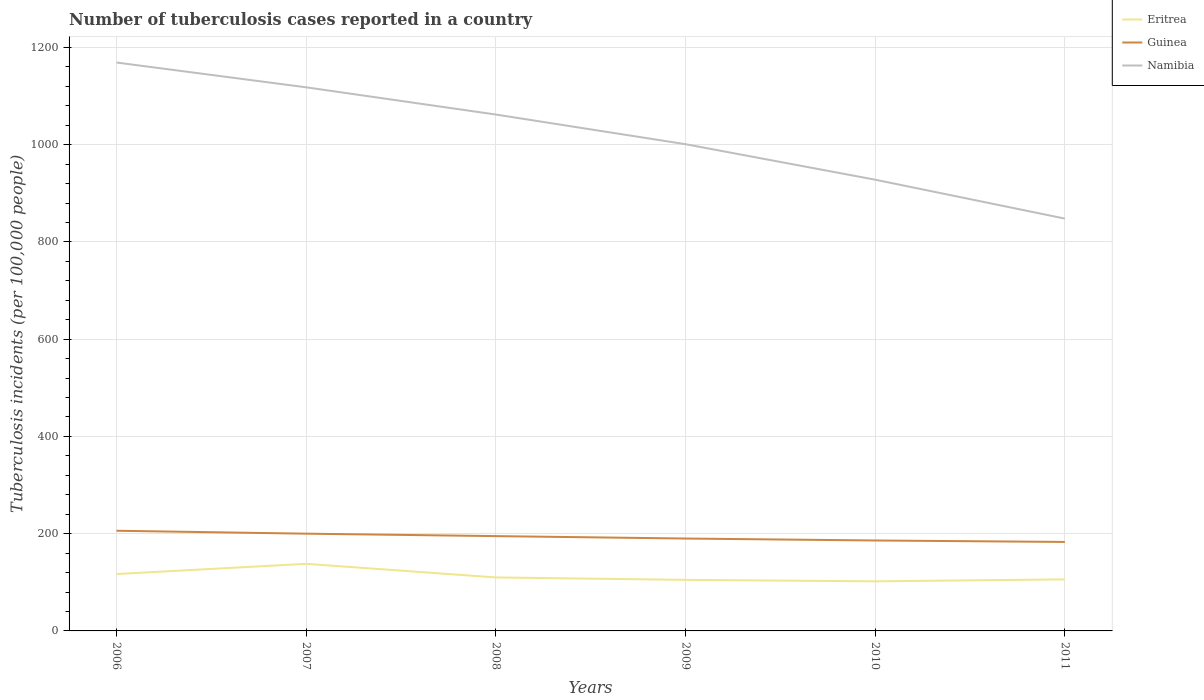Does the line corresponding to Eritrea intersect with the line corresponding to Namibia?
Provide a succinct answer. No. Across all years, what is the maximum number of tuberculosis cases reported in in Guinea?
Keep it short and to the point. 183. What is the total number of tuberculosis cases reported in in Eritrea in the graph?
Keep it short and to the point. 32. What is the difference between the highest and the second highest number of tuberculosis cases reported in in Namibia?
Your answer should be compact. 321. What is the difference between the highest and the lowest number of tuberculosis cases reported in in Guinea?
Your response must be concise. 3. Is the number of tuberculosis cases reported in in Guinea strictly greater than the number of tuberculosis cases reported in in Eritrea over the years?
Offer a very short reply. No. How many lines are there?
Offer a very short reply. 3. How many years are there in the graph?
Provide a short and direct response. 6. What is the difference between two consecutive major ticks on the Y-axis?
Provide a succinct answer. 200. Does the graph contain grids?
Your response must be concise. Yes. Where does the legend appear in the graph?
Your response must be concise. Top right. How many legend labels are there?
Your response must be concise. 3. How are the legend labels stacked?
Provide a succinct answer. Vertical. What is the title of the graph?
Ensure brevity in your answer.  Number of tuberculosis cases reported in a country. What is the label or title of the Y-axis?
Your answer should be compact. Tuberculosis incidents (per 100,0 people). What is the Tuberculosis incidents (per 100,000 people) in Eritrea in 2006?
Keep it short and to the point. 117. What is the Tuberculosis incidents (per 100,000 people) in Guinea in 2006?
Provide a short and direct response. 206. What is the Tuberculosis incidents (per 100,000 people) in Namibia in 2006?
Your answer should be very brief. 1169. What is the Tuberculosis incidents (per 100,000 people) of Eritrea in 2007?
Offer a very short reply. 138. What is the Tuberculosis incidents (per 100,000 people) in Guinea in 2007?
Your answer should be compact. 200. What is the Tuberculosis incidents (per 100,000 people) in Namibia in 2007?
Give a very brief answer. 1118. What is the Tuberculosis incidents (per 100,000 people) of Eritrea in 2008?
Keep it short and to the point. 110. What is the Tuberculosis incidents (per 100,000 people) of Guinea in 2008?
Ensure brevity in your answer.  195. What is the Tuberculosis incidents (per 100,000 people) of Namibia in 2008?
Your response must be concise. 1062. What is the Tuberculosis incidents (per 100,000 people) in Eritrea in 2009?
Make the answer very short. 105. What is the Tuberculosis incidents (per 100,000 people) of Guinea in 2009?
Provide a short and direct response. 190. What is the Tuberculosis incidents (per 100,000 people) in Namibia in 2009?
Your response must be concise. 1001. What is the Tuberculosis incidents (per 100,000 people) of Eritrea in 2010?
Make the answer very short. 102. What is the Tuberculosis incidents (per 100,000 people) in Guinea in 2010?
Your response must be concise. 186. What is the Tuberculosis incidents (per 100,000 people) of Namibia in 2010?
Give a very brief answer. 928. What is the Tuberculosis incidents (per 100,000 people) in Eritrea in 2011?
Offer a very short reply. 106. What is the Tuberculosis incidents (per 100,000 people) of Guinea in 2011?
Provide a short and direct response. 183. What is the Tuberculosis incidents (per 100,000 people) of Namibia in 2011?
Your answer should be very brief. 848. Across all years, what is the maximum Tuberculosis incidents (per 100,000 people) of Eritrea?
Keep it short and to the point. 138. Across all years, what is the maximum Tuberculosis incidents (per 100,000 people) in Guinea?
Your response must be concise. 206. Across all years, what is the maximum Tuberculosis incidents (per 100,000 people) in Namibia?
Keep it short and to the point. 1169. Across all years, what is the minimum Tuberculosis incidents (per 100,000 people) in Eritrea?
Offer a terse response. 102. Across all years, what is the minimum Tuberculosis incidents (per 100,000 people) in Guinea?
Provide a succinct answer. 183. Across all years, what is the minimum Tuberculosis incidents (per 100,000 people) in Namibia?
Provide a short and direct response. 848. What is the total Tuberculosis incidents (per 100,000 people) in Eritrea in the graph?
Your response must be concise. 678. What is the total Tuberculosis incidents (per 100,000 people) in Guinea in the graph?
Offer a very short reply. 1160. What is the total Tuberculosis incidents (per 100,000 people) of Namibia in the graph?
Provide a short and direct response. 6126. What is the difference between the Tuberculosis incidents (per 100,000 people) of Eritrea in 2006 and that in 2008?
Give a very brief answer. 7. What is the difference between the Tuberculosis incidents (per 100,000 people) in Namibia in 2006 and that in 2008?
Offer a very short reply. 107. What is the difference between the Tuberculosis incidents (per 100,000 people) in Guinea in 2006 and that in 2009?
Provide a short and direct response. 16. What is the difference between the Tuberculosis incidents (per 100,000 people) of Namibia in 2006 and that in 2009?
Your answer should be very brief. 168. What is the difference between the Tuberculosis incidents (per 100,000 people) of Eritrea in 2006 and that in 2010?
Make the answer very short. 15. What is the difference between the Tuberculosis incidents (per 100,000 people) of Guinea in 2006 and that in 2010?
Offer a very short reply. 20. What is the difference between the Tuberculosis incidents (per 100,000 people) of Namibia in 2006 and that in 2010?
Your answer should be very brief. 241. What is the difference between the Tuberculosis incidents (per 100,000 people) of Eritrea in 2006 and that in 2011?
Your answer should be compact. 11. What is the difference between the Tuberculosis incidents (per 100,000 people) in Namibia in 2006 and that in 2011?
Your answer should be compact. 321. What is the difference between the Tuberculosis incidents (per 100,000 people) in Eritrea in 2007 and that in 2008?
Your response must be concise. 28. What is the difference between the Tuberculosis incidents (per 100,000 people) in Guinea in 2007 and that in 2009?
Make the answer very short. 10. What is the difference between the Tuberculosis incidents (per 100,000 people) of Namibia in 2007 and that in 2009?
Keep it short and to the point. 117. What is the difference between the Tuberculosis incidents (per 100,000 people) in Eritrea in 2007 and that in 2010?
Your answer should be compact. 36. What is the difference between the Tuberculosis incidents (per 100,000 people) of Guinea in 2007 and that in 2010?
Offer a very short reply. 14. What is the difference between the Tuberculosis incidents (per 100,000 people) of Namibia in 2007 and that in 2010?
Your answer should be very brief. 190. What is the difference between the Tuberculosis incidents (per 100,000 people) of Guinea in 2007 and that in 2011?
Keep it short and to the point. 17. What is the difference between the Tuberculosis incidents (per 100,000 people) in Namibia in 2007 and that in 2011?
Provide a short and direct response. 270. What is the difference between the Tuberculosis incidents (per 100,000 people) of Eritrea in 2008 and that in 2009?
Provide a short and direct response. 5. What is the difference between the Tuberculosis incidents (per 100,000 people) in Guinea in 2008 and that in 2010?
Offer a very short reply. 9. What is the difference between the Tuberculosis incidents (per 100,000 people) in Namibia in 2008 and that in 2010?
Offer a terse response. 134. What is the difference between the Tuberculosis incidents (per 100,000 people) in Guinea in 2008 and that in 2011?
Provide a short and direct response. 12. What is the difference between the Tuberculosis incidents (per 100,000 people) of Namibia in 2008 and that in 2011?
Your answer should be very brief. 214. What is the difference between the Tuberculosis incidents (per 100,000 people) in Eritrea in 2009 and that in 2010?
Your answer should be very brief. 3. What is the difference between the Tuberculosis incidents (per 100,000 people) in Guinea in 2009 and that in 2010?
Provide a short and direct response. 4. What is the difference between the Tuberculosis incidents (per 100,000 people) of Guinea in 2009 and that in 2011?
Offer a terse response. 7. What is the difference between the Tuberculosis incidents (per 100,000 people) of Namibia in 2009 and that in 2011?
Keep it short and to the point. 153. What is the difference between the Tuberculosis incidents (per 100,000 people) in Eritrea in 2010 and that in 2011?
Give a very brief answer. -4. What is the difference between the Tuberculosis incidents (per 100,000 people) in Eritrea in 2006 and the Tuberculosis incidents (per 100,000 people) in Guinea in 2007?
Your answer should be very brief. -83. What is the difference between the Tuberculosis incidents (per 100,000 people) in Eritrea in 2006 and the Tuberculosis incidents (per 100,000 people) in Namibia in 2007?
Your answer should be compact. -1001. What is the difference between the Tuberculosis incidents (per 100,000 people) of Guinea in 2006 and the Tuberculosis incidents (per 100,000 people) of Namibia in 2007?
Offer a terse response. -912. What is the difference between the Tuberculosis incidents (per 100,000 people) of Eritrea in 2006 and the Tuberculosis incidents (per 100,000 people) of Guinea in 2008?
Offer a very short reply. -78. What is the difference between the Tuberculosis incidents (per 100,000 people) in Eritrea in 2006 and the Tuberculosis incidents (per 100,000 people) in Namibia in 2008?
Provide a short and direct response. -945. What is the difference between the Tuberculosis incidents (per 100,000 people) in Guinea in 2006 and the Tuberculosis incidents (per 100,000 people) in Namibia in 2008?
Your answer should be very brief. -856. What is the difference between the Tuberculosis incidents (per 100,000 people) of Eritrea in 2006 and the Tuberculosis incidents (per 100,000 people) of Guinea in 2009?
Your answer should be very brief. -73. What is the difference between the Tuberculosis incidents (per 100,000 people) in Eritrea in 2006 and the Tuberculosis incidents (per 100,000 people) in Namibia in 2009?
Provide a short and direct response. -884. What is the difference between the Tuberculosis incidents (per 100,000 people) of Guinea in 2006 and the Tuberculosis incidents (per 100,000 people) of Namibia in 2009?
Make the answer very short. -795. What is the difference between the Tuberculosis incidents (per 100,000 people) in Eritrea in 2006 and the Tuberculosis incidents (per 100,000 people) in Guinea in 2010?
Ensure brevity in your answer.  -69. What is the difference between the Tuberculosis incidents (per 100,000 people) in Eritrea in 2006 and the Tuberculosis incidents (per 100,000 people) in Namibia in 2010?
Provide a short and direct response. -811. What is the difference between the Tuberculosis incidents (per 100,000 people) in Guinea in 2006 and the Tuberculosis incidents (per 100,000 people) in Namibia in 2010?
Give a very brief answer. -722. What is the difference between the Tuberculosis incidents (per 100,000 people) in Eritrea in 2006 and the Tuberculosis incidents (per 100,000 people) in Guinea in 2011?
Offer a very short reply. -66. What is the difference between the Tuberculosis incidents (per 100,000 people) of Eritrea in 2006 and the Tuberculosis incidents (per 100,000 people) of Namibia in 2011?
Make the answer very short. -731. What is the difference between the Tuberculosis incidents (per 100,000 people) of Guinea in 2006 and the Tuberculosis incidents (per 100,000 people) of Namibia in 2011?
Make the answer very short. -642. What is the difference between the Tuberculosis incidents (per 100,000 people) in Eritrea in 2007 and the Tuberculosis incidents (per 100,000 people) in Guinea in 2008?
Offer a terse response. -57. What is the difference between the Tuberculosis incidents (per 100,000 people) in Eritrea in 2007 and the Tuberculosis incidents (per 100,000 people) in Namibia in 2008?
Ensure brevity in your answer.  -924. What is the difference between the Tuberculosis incidents (per 100,000 people) in Guinea in 2007 and the Tuberculosis incidents (per 100,000 people) in Namibia in 2008?
Keep it short and to the point. -862. What is the difference between the Tuberculosis incidents (per 100,000 people) of Eritrea in 2007 and the Tuberculosis incidents (per 100,000 people) of Guinea in 2009?
Your answer should be compact. -52. What is the difference between the Tuberculosis incidents (per 100,000 people) in Eritrea in 2007 and the Tuberculosis incidents (per 100,000 people) in Namibia in 2009?
Make the answer very short. -863. What is the difference between the Tuberculosis incidents (per 100,000 people) in Guinea in 2007 and the Tuberculosis incidents (per 100,000 people) in Namibia in 2009?
Your response must be concise. -801. What is the difference between the Tuberculosis incidents (per 100,000 people) in Eritrea in 2007 and the Tuberculosis incidents (per 100,000 people) in Guinea in 2010?
Provide a succinct answer. -48. What is the difference between the Tuberculosis incidents (per 100,000 people) of Eritrea in 2007 and the Tuberculosis incidents (per 100,000 people) of Namibia in 2010?
Your answer should be very brief. -790. What is the difference between the Tuberculosis incidents (per 100,000 people) in Guinea in 2007 and the Tuberculosis incidents (per 100,000 people) in Namibia in 2010?
Make the answer very short. -728. What is the difference between the Tuberculosis incidents (per 100,000 people) in Eritrea in 2007 and the Tuberculosis incidents (per 100,000 people) in Guinea in 2011?
Offer a very short reply. -45. What is the difference between the Tuberculosis incidents (per 100,000 people) of Eritrea in 2007 and the Tuberculosis incidents (per 100,000 people) of Namibia in 2011?
Provide a short and direct response. -710. What is the difference between the Tuberculosis incidents (per 100,000 people) in Guinea in 2007 and the Tuberculosis incidents (per 100,000 people) in Namibia in 2011?
Ensure brevity in your answer.  -648. What is the difference between the Tuberculosis incidents (per 100,000 people) of Eritrea in 2008 and the Tuberculosis incidents (per 100,000 people) of Guinea in 2009?
Ensure brevity in your answer.  -80. What is the difference between the Tuberculosis incidents (per 100,000 people) of Eritrea in 2008 and the Tuberculosis incidents (per 100,000 people) of Namibia in 2009?
Your answer should be compact. -891. What is the difference between the Tuberculosis incidents (per 100,000 people) of Guinea in 2008 and the Tuberculosis incidents (per 100,000 people) of Namibia in 2009?
Your answer should be very brief. -806. What is the difference between the Tuberculosis incidents (per 100,000 people) in Eritrea in 2008 and the Tuberculosis incidents (per 100,000 people) in Guinea in 2010?
Make the answer very short. -76. What is the difference between the Tuberculosis incidents (per 100,000 people) of Eritrea in 2008 and the Tuberculosis incidents (per 100,000 people) of Namibia in 2010?
Make the answer very short. -818. What is the difference between the Tuberculosis incidents (per 100,000 people) of Guinea in 2008 and the Tuberculosis incidents (per 100,000 people) of Namibia in 2010?
Provide a succinct answer. -733. What is the difference between the Tuberculosis incidents (per 100,000 people) of Eritrea in 2008 and the Tuberculosis incidents (per 100,000 people) of Guinea in 2011?
Provide a short and direct response. -73. What is the difference between the Tuberculosis incidents (per 100,000 people) in Eritrea in 2008 and the Tuberculosis incidents (per 100,000 people) in Namibia in 2011?
Give a very brief answer. -738. What is the difference between the Tuberculosis incidents (per 100,000 people) of Guinea in 2008 and the Tuberculosis incidents (per 100,000 people) of Namibia in 2011?
Provide a succinct answer. -653. What is the difference between the Tuberculosis incidents (per 100,000 people) of Eritrea in 2009 and the Tuberculosis incidents (per 100,000 people) of Guinea in 2010?
Provide a short and direct response. -81. What is the difference between the Tuberculosis incidents (per 100,000 people) of Eritrea in 2009 and the Tuberculosis incidents (per 100,000 people) of Namibia in 2010?
Your answer should be compact. -823. What is the difference between the Tuberculosis incidents (per 100,000 people) in Guinea in 2009 and the Tuberculosis incidents (per 100,000 people) in Namibia in 2010?
Provide a succinct answer. -738. What is the difference between the Tuberculosis incidents (per 100,000 people) of Eritrea in 2009 and the Tuberculosis incidents (per 100,000 people) of Guinea in 2011?
Offer a very short reply. -78. What is the difference between the Tuberculosis incidents (per 100,000 people) in Eritrea in 2009 and the Tuberculosis incidents (per 100,000 people) in Namibia in 2011?
Your answer should be compact. -743. What is the difference between the Tuberculosis incidents (per 100,000 people) of Guinea in 2009 and the Tuberculosis incidents (per 100,000 people) of Namibia in 2011?
Keep it short and to the point. -658. What is the difference between the Tuberculosis incidents (per 100,000 people) in Eritrea in 2010 and the Tuberculosis incidents (per 100,000 people) in Guinea in 2011?
Give a very brief answer. -81. What is the difference between the Tuberculosis incidents (per 100,000 people) of Eritrea in 2010 and the Tuberculosis incidents (per 100,000 people) of Namibia in 2011?
Provide a succinct answer. -746. What is the difference between the Tuberculosis incidents (per 100,000 people) in Guinea in 2010 and the Tuberculosis incidents (per 100,000 people) in Namibia in 2011?
Provide a short and direct response. -662. What is the average Tuberculosis incidents (per 100,000 people) of Eritrea per year?
Provide a succinct answer. 113. What is the average Tuberculosis incidents (per 100,000 people) in Guinea per year?
Keep it short and to the point. 193.33. What is the average Tuberculosis incidents (per 100,000 people) in Namibia per year?
Your answer should be compact. 1021. In the year 2006, what is the difference between the Tuberculosis incidents (per 100,000 people) of Eritrea and Tuberculosis incidents (per 100,000 people) of Guinea?
Make the answer very short. -89. In the year 2006, what is the difference between the Tuberculosis incidents (per 100,000 people) in Eritrea and Tuberculosis incidents (per 100,000 people) in Namibia?
Provide a succinct answer. -1052. In the year 2006, what is the difference between the Tuberculosis incidents (per 100,000 people) of Guinea and Tuberculosis incidents (per 100,000 people) of Namibia?
Ensure brevity in your answer.  -963. In the year 2007, what is the difference between the Tuberculosis incidents (per 100,000 people) in Eritrea and Tuberculosis incidents (per 100,000 people) in Guinea?
Keep it short and to the point. -62. In the year 2007, what is the difference between the Tuberculosis incidents (per 100,000 people) in Eritrea and Tuberculosis incidents (per 100,000 people) in Namibia?
Provide a short and direct response. -980. In the year 2007, what is the difference between the Tuberculosis incidents (per 100,000 people) in Guinea and Tuberculosis incidents (per 100,000 people) in Namibia?
Provide a succinct answer. -918. In the year 2008, what is the difference between the Tuberculosis incidents (per 100,000 people) in Eritrea and Tuberculosis incidents (per 100,000 people) in Guinea?
Keep it short and to the point. -85. In the year 2008, what is the difference between the Tuberculosis incidents (per 100,000 people) of Eritrea and Tuberculosis incidents (per 100,000 people) of Namibia?
Keep it short and to the point. -952. In the year 2008, what is the difference between the Tuberculosis incidents (per 100,000 people) in Guinea and Tuberculosis incidents (per 100,000 people) in Namibia?
Give a very brief answer. -867. In the year 2009, what is the difference between the Tuberculosis incidents (per 100,000 people) of Eritrea and Tuberculosis incidents (per 100,000 people) of Guinea?
Ensure brevity in your answer.  -85. In the year 2009, what is the difference between the Tuberculosis incidents (per 100,000 people) of Eritrea and Tuberculosis incidents (per 100,000 people) of Namibia?
Your response must be concise. -896. In the year 2009, what is the difference between the Tuberculosis incidents (per 100,000 people) in Guinea and Tuberculosis incidents (per 100,000 people) in Namibia?
Give a very brief answer. -811. In the year 2010, what is the difference between the Tuberculosis incidents (per 100,000 people) in Eritrea and Tuberculosis incidents (per 100,000 people) in Guinea?
Ensure brevity in your answer.  -84. In the year 2010, what is the difference between the Tuberculosis incidents (per 100,000 people) of Eritrea and Tuberculosis incidents (per 100,000 people) of Namibia?
Your answer should be very brief. -826. In the year 2010, what is the difference between the Tuberculosis incidents (per 100,000 people) of Guinea and Tuberculosis incidents (per 100,000 people) of Namibia?
Give a very brief answer. -742. In the year 2011, what is the difference between the Tuberculosis incidents (per 100,000 people) of Eritrea and Tuberculosis incidents (per 100,000 people) of Guinea?
Your answer should be very brief. -77. In the year 2011, what is the difference between the Tuberculosis incidents (per 100,000 people) in Eritrea and Tuberculosis incidents (per 100,000 people) in Namibia?
Your answer should be very brief. -742. In the year 2011, what is the difference between the Tuberculosis incidents (per 100,000 people) of Guinea and Tuberculosis incidents (per 100,000 people) of Namibia?
Give a very brief answer. -665. What is the ratio of the Tuberculosis incidents (per 100,000 people) of Eritrea in 2006 to that in 2007?
Provide a short and direct response. 0.85. What is the ratio of the Tuberculosis incidents (per 100,000 people) of Namibia in 2006 to that in 2007?
Provide a short and direct response. 1.05. What is the ratio of the Tuberculosis incidents (per 100,000 people) of Eritrea in 2006 to that in 2008?
Offer a very short reply. 1.06. What is the ratio of the Tuberculosis incidents (per 100,000 people) of Guinea in 2006 to that in 2008?
Keep it short and to the point. 1.06. What is the ratio of the Tuberculosis incidents (per 100,000 people) of Namibia in 2006 to that in 2008?
Provide a succinct answer. 1.1. What is the ratio of the Tuberculosis incidents (per 100,000 people) of Eritrea in 2006 to that in 2009?
Provide a succinct answer. 1.11. What is the ratio of the Tuberculosis incidents (per 100,000 people) of Guinea in 2006 to that in 2009?
Keep it short and to the point. 1.08. What is the ratio of the Tuberculosis incidents (per 100,000 people) in Namibia in 2006 to that in 2009?
Make the answer very short. 1.17. What is the ratio of the Tuberculosis incidents (per 100,000 people) of Eritrea in 2006 to that in 2010?
Your response must be concise. 1.15. What is the ratio of the Tuberculosis incidents (per 100,000 people) of Guinea in 2006 to that in 2010?
Your response must be concise. 1.11. What is the ratio of the Tuberculosis incidents (per 100,000 people) in Namibia in 2006 to that in 2010?
Your response must be concise. 1.26. What is the ratio of the Tuberculosis incidents (per 100,000 people) of Eritrea in 2006 to that in 2011?
Provide a succinct answer. 1.1. What is the ratio of the Tuberculosis incidents (per 100,000 people) of Guinea in 2006 to that in 2011?
Offer a very short reply. 1.13. What is the ratio of the Tuberculosis incidents (per 100,000 people) of Namibia in 2006 to that in 2011?
Offer a very short reply. 1.38. What is the ratio of the Tuberculosis incidents (per 100,000 people) of Eritrea in 2007 to that in 2008?
Offer a terse response. 1.25. What is the ratio of the Tuberculosis incidents (per 100,000 people) of Guinea in 2007 to that in 2008?
Provide a succinct answer. 1.03. What is the ratio of the Tuberculosis incidents (per 100,000 people) of Namibia in 2007 to that in 2008?
Keep it short and to the point. 1.05. What is the ratio of the Tuberculosis incidents (per 100,000 people) in Eritrea in 2007 to that in 2009?
Offer a very short reply. 1.31. What is the ratio of the Tuberculosis incidents (per 100,000 people) of Guinea in 2007 to that in 2009?
Offer a terse response. 1.05. What is the ratio of the Tuberculosis incidents (per 100,000 people) of Namibia in 2007 to that in 2009?
Your answer should be very brief. 1.12. What is the ratio of the Tuberculosis incidents (per 100,000 people) in Eritrea in 2007 to that in 2010?
Give a very brief answer. 1.35. What is the ratio of the Tuberculosis incidents (per 100,000 people) of Guinea in 2007 to that in 2010?
Your response must be concise. 1.08. What is the ratio of the Tuberculosis incidents (per 100,000 people) in Namibia in 2007 to that in 2010?
Your answer should be very brief. 1.2. What is the ratio of the Tuberculosis incidents (per 100,000 people) of Eritrea in 2007 to that in 2011?
Give a very brief answer. 1.3. What is the ratio of the Tuberculosis incidents (per 100,000 people) in Guinea in 2007 to that in 2011?
Offer a terse response. 1.09. What is the ratio of the Tuberculosis incidents (per 100,000 people) in Namibia in 2007 to that in 2011?
Offer a very short reply. 1.32. What is the ratio of the Tuberculosis incidents (per 100,000 people) of Eritrea in 2008 to that in 2009?
Ensure brevity in your answer.  1.05. What is the ratio of the Tuberculosis incidents (per 100,000 people) of Guinea in 2008 to that in 2009?
Keep it short and to the point. 1.03. What is the ratio of the Tuberculosis incidents (per 100,000 people) in Namibia in 2008 to that in 2009?
Ensure brevity in your answer.  1.06. What is the ratio of the Tuberculosis incidents (per 100,000 people) in Eritrea in 2008 to that in 2010?
Give a very brief answer. 1.08. What is the ratio of the Tuberculosis incidents (per 100,000 people) of Guinea in 2008 to that in 2010?
Provide a short and direct response. 1.05. What is the ratio of the Tuberculosis incidents (per 100,000 people) of Namibia in 2008 to that in 2010?
Ensure brevity in your answer.  1.14. What is the ratio of the Tuberculosis incidents (per 100,000 people) of Eritrea in 2008 to that in 2011?
Ensure brevity in your answer.  1.04. What is the ratio of the Tuberculosis incidents (per 100,000 people) in Guinea in 2008 to that in 2011?
Offer a terse response. 1.07. What is the ratio of the Tuberculosis incidents (per 100,000 people) of Namibia in 2008 to that in 2011?
Keep it short and to the point. 1.25. What is the ratio of the Tuberculosis incidents (per 100,000 people) of Eritrea in 2009 to that in 2010?
Your answer should be compact. 1.03. What is the ratio of the Tuberculosis incidents (per 100,000 people) of Guinea in 2009 to that in 2010?
Provide a succinct answer. 1.02. What is the ratio of the Tuberculosis incidents (per 100,000 people) in Namibia in 2009 to that in 2010?
Your answer should be compact. 1.08. What is the ratio of the Tuberculosis incidents (per 100,000 people) in Eritrea in 2009 to that in 2011?
Your answer should be compact. 0.99. What is the ratio of the Tuberculosis incidents (per 100,000 people) of Guinea in 2009 to that in 2011?
Provide a succinct answer. 1.04. What is the ratio of the Tuberculosis incidents (per 100,000 people) of Namibia in 2009 to that in 2011?
Make the answer very short. 1.18. What is the ratio of the Tuberculosis incidents (per 100,000 people) of Eritrea in 2010 to that in 2011?
Your response must be concise. 0.96. What is the ratio of the Tuberculosis incidents (per 100,000 people) of Guinea in 2010 to that in 2011?
Keep it short and to the point. 1.02. What is the ratio of the Tuberculosis incidents (per 100,000 people) in Namibia in 2010 to that in 2011?
Offer a very short reply. 1.09. What is the difference between the highest and the second highest Tuberculosis incidents (per 100,000 people) of Eritrea?
Provide a succinct answer. 21. What is the difference between the highest and the second highest Tuberculosis incidents (per 100,000 people) in Guinea?
Give a very brief answer. 6. What is the difference between the highest and the lowest Tuberculosis incidents (per 100,000 people) of Guinea?
Make the answer very short. 23. What is the difference between the highest and the lowest Tuberculosis incidents (per 100,000 people) in Namibia?
Provide a short and direct response. 321. 